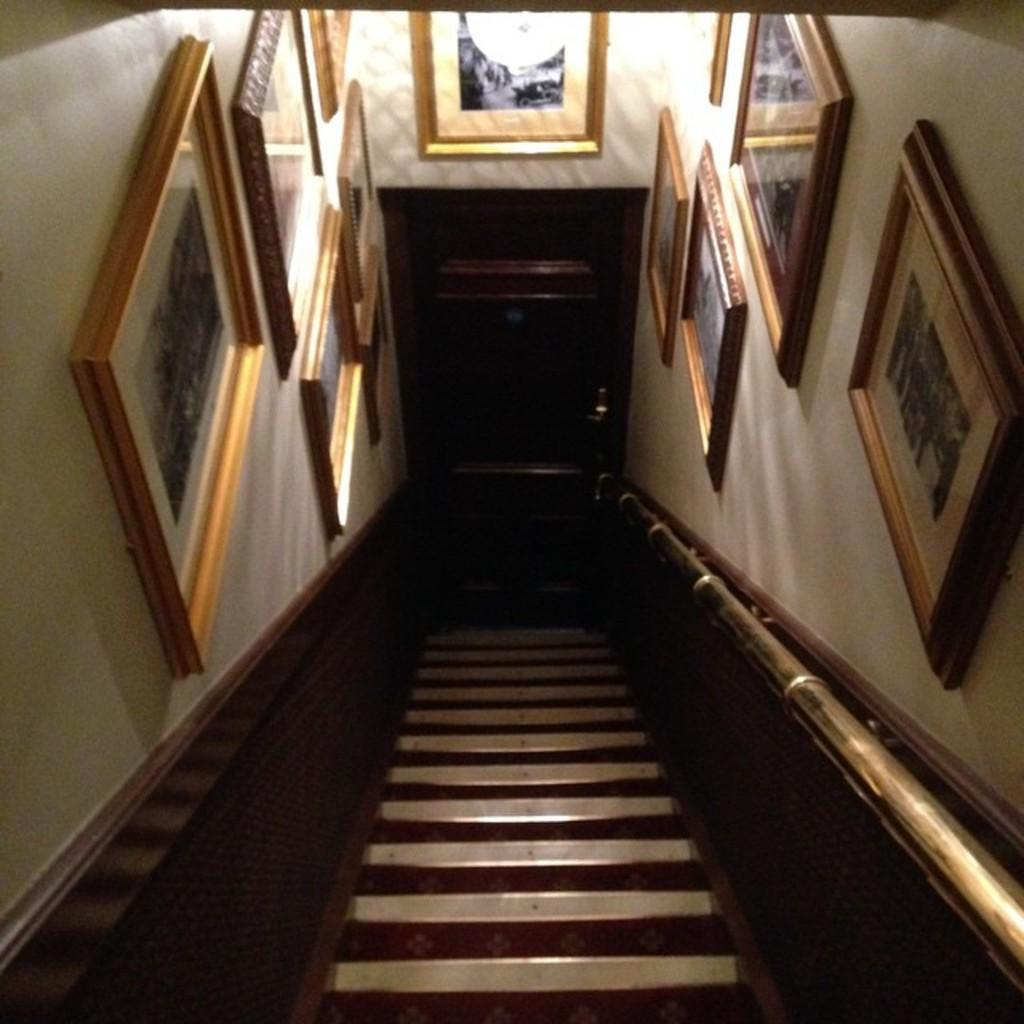What type of structure is present in the image? There are stairs in the image. What object can be seen near the stairs? There is an iron rod in the image. What can be used for illumination in the image? There is a light in the image. What type of decorative elements are attached to the wall in the image? There are frames attached to the wall in the image. What time of day is it in the image? The time of day cannot be determined from the image, as there are no clues or indicators of the time. 